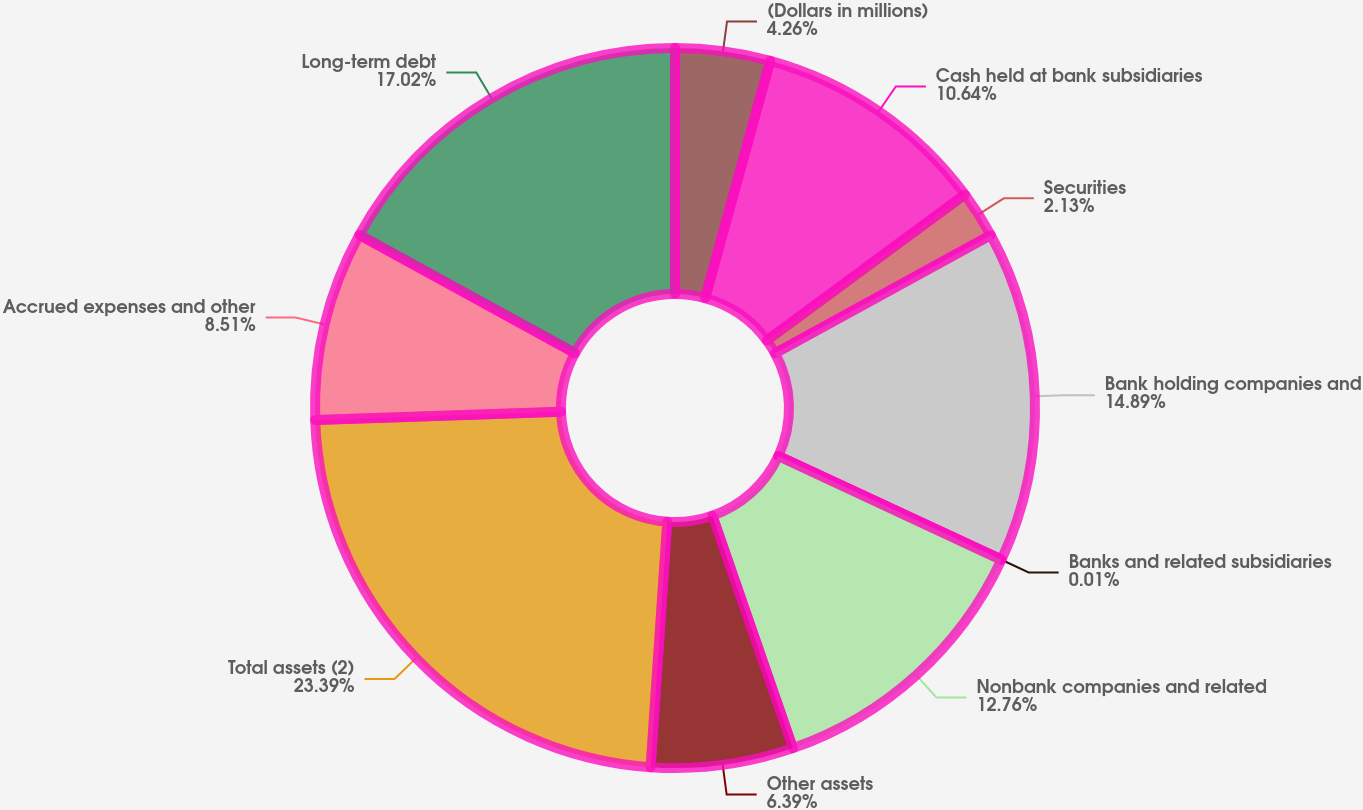<chart> <loc_0><loc_0><loc_500><loc_500><pie_chart><fcel>(Dollars in millions)<fcel>Cash held at bank subsidiaries<fcel>Securities<fcel>Bank holding companies and<fcel>Banks and related subsidiaries<fcel>Nonbank companies and related<fcel>Other assets<fcel>Total assets (2)<fcel>Accrued expenses and other<fcel>Long-term debt<nl><fcel>4.26%<fcel>10.64%<fcel>2.13%<fcel>14.89%<fcel>0.01%<fcel>12.76%<fcel>6.39%<fcel>23.39%<fcel>8.51%<fcel>17.02%<nl></chart> 